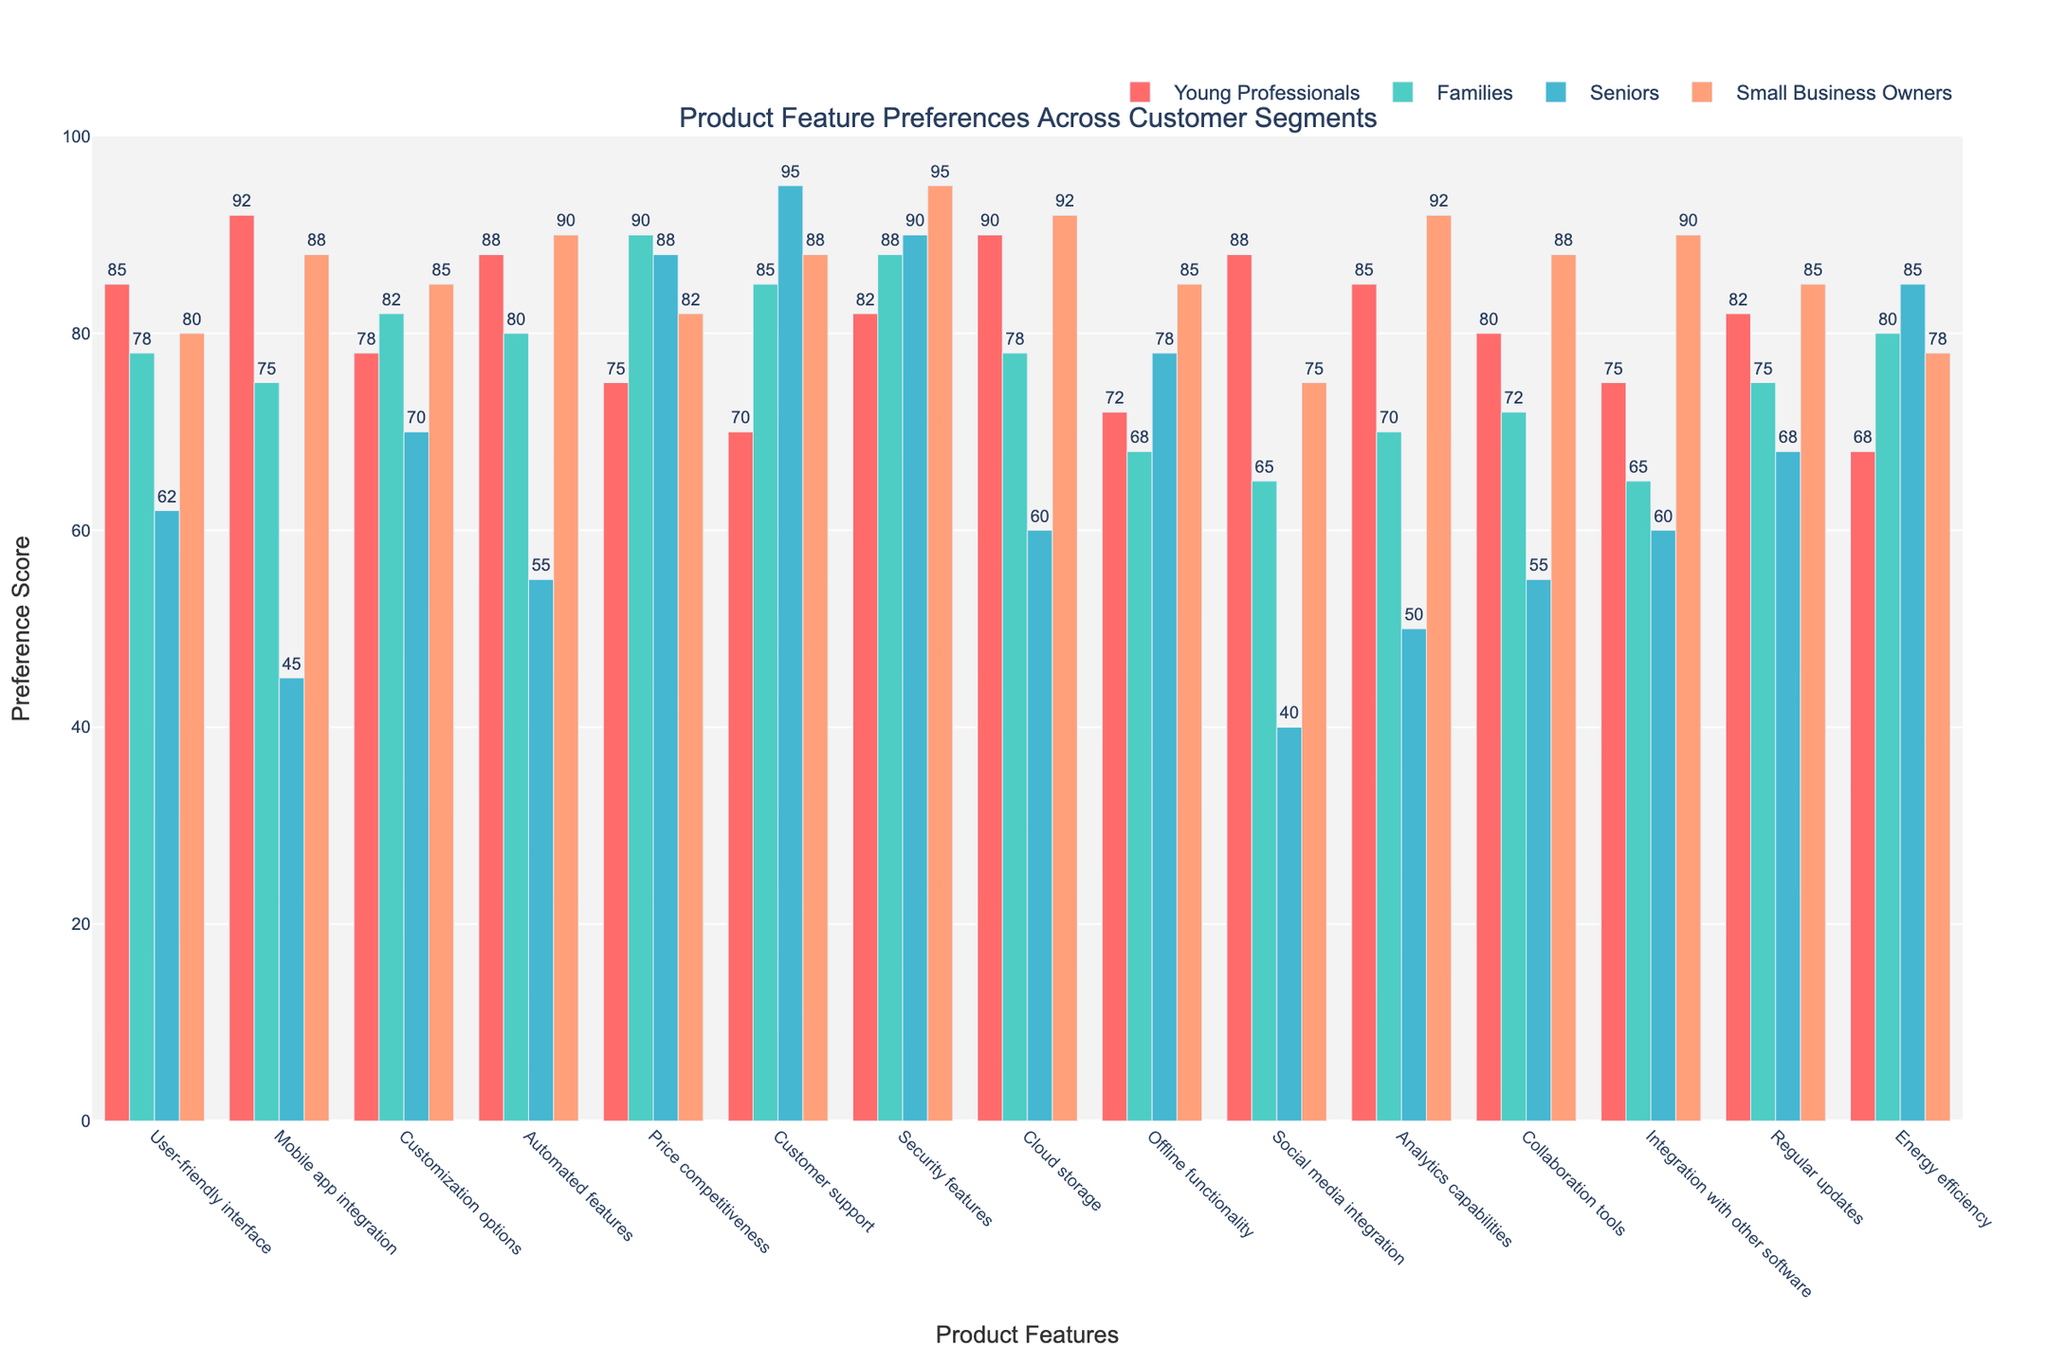Which feature is most preferred by Young Professionals? The highest bar in the Young Professionals category indicates their most preferred feature. The tallest bar corresponds to "Mobile app integration" with a preference score of 92.
Answer: Mobile app integration How do the preferences for "Customer support" compare between Families and Small Business Owners? Compare the heights of the bars for "Customer support" between Families and Small Business Owners. The figure shows that Families have a score of 85, while Small Business Owners have a score of 88.
Answer: Small Business Owners prefer it more Which customer segment has the highest preference for "Security features"? Find the tallest bar in the "Security features" category. The data shows that Seniors have the highest preference with a score of 90.
Answer: Seniors What is the average preference score for "Cloud storage" across all customer segments? Sum the preference scores for "Cloud storage" across all segments (90 for Young Professionals, 78 for Families, 60 for Seniors, and 92 for Small Business Owners) and divide by the number of segments (4). (90 + 78 + 60 + 92) / 4 = 80
Answer: 80 Which feature has the largest preference difference between Young Professionals and Seniors? Calculate the difference in preference scores for each feature between Young Professionals and Seniors. The largest difference is for "Mobile app integration" (92-45=47).
Answer: Mobile app integration Is the preference for "Offline functionality" higher in Families or Seniors, and by how much? Compare the heights of the bars for "Offline functionality" between Families and Seniors. Families have a score of 68, and Seniors have a score of 78. The difference is 78 - 68 = 10.
Answer: Seniors by 10 How does the preference for "Social media integration" differ between Small Business Owners and Seniors? Look at the preference scores for "Social media integration" for both segments. Small Business Owners have a score of 75, whereas Seniors have a score of 40. The difference is 75 - 40 = 35.
Answer: Small Business Owners prefer it more by 35 For which feature is the preference between Families and Small Business Owners equal? Identify the features where the bars for Families and Small Business Owners are of equal height. For "Regular updates", both segments have a preference score of 85.
Answer: Regular updates What is the second most preferred feature for Families? Find the second highest bar in the Families category. The highest bar is for "Price competitiveness" (90), and the second highest is for "Customer support" (85).
Answer: Customer support 